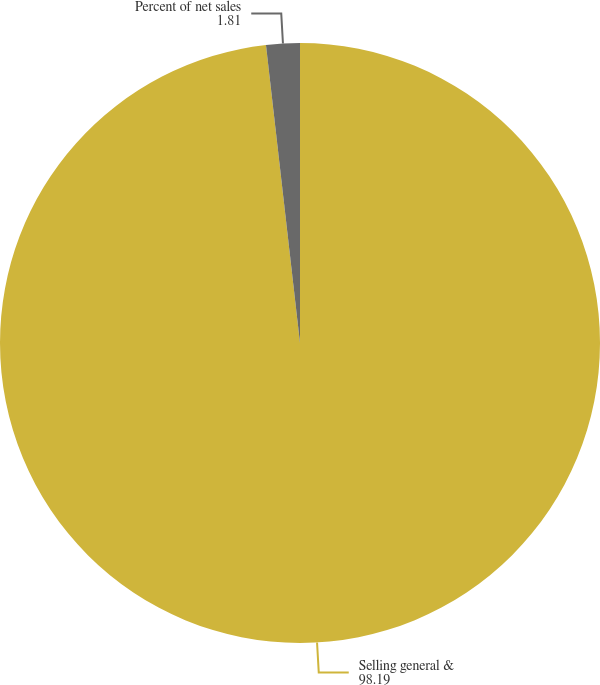Convert chart to OTSL. <chart><loc_0><loc_0><loc_500><loc_500><pie_chart><fcel>Selling general &<fcel>Percent of net sales<nl><fcel>98.19%<fcel>1.81%<nl></chart> 